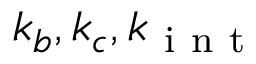Convert formula to latex. <formula><loc_0><loc_0><loc_500><loc_500>k _ { b } , k _ { c } , k _ { i n t }</formula> 